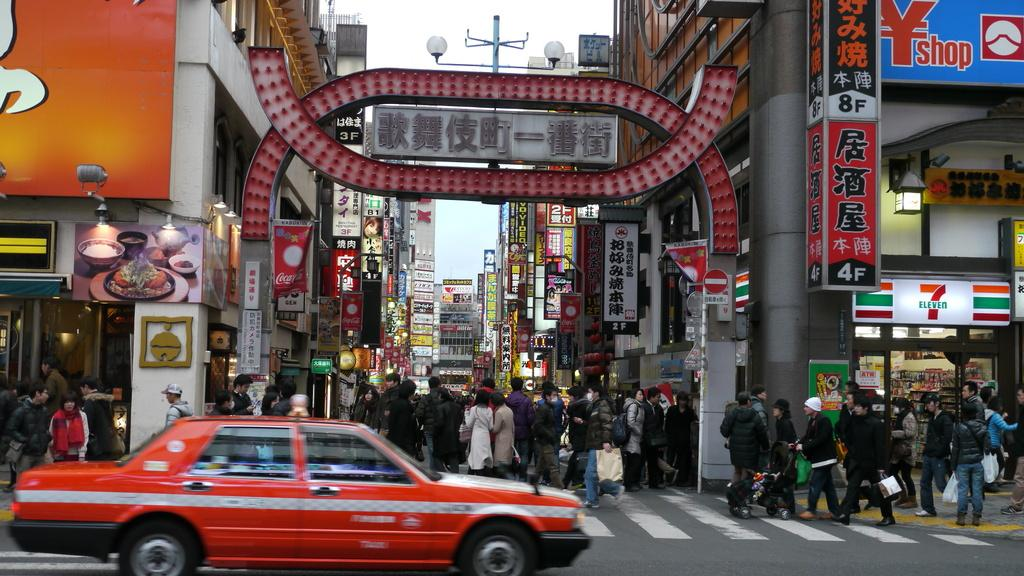<image>
Render a clear and concise summary of the photo. One of the signs in a business district says YShop 